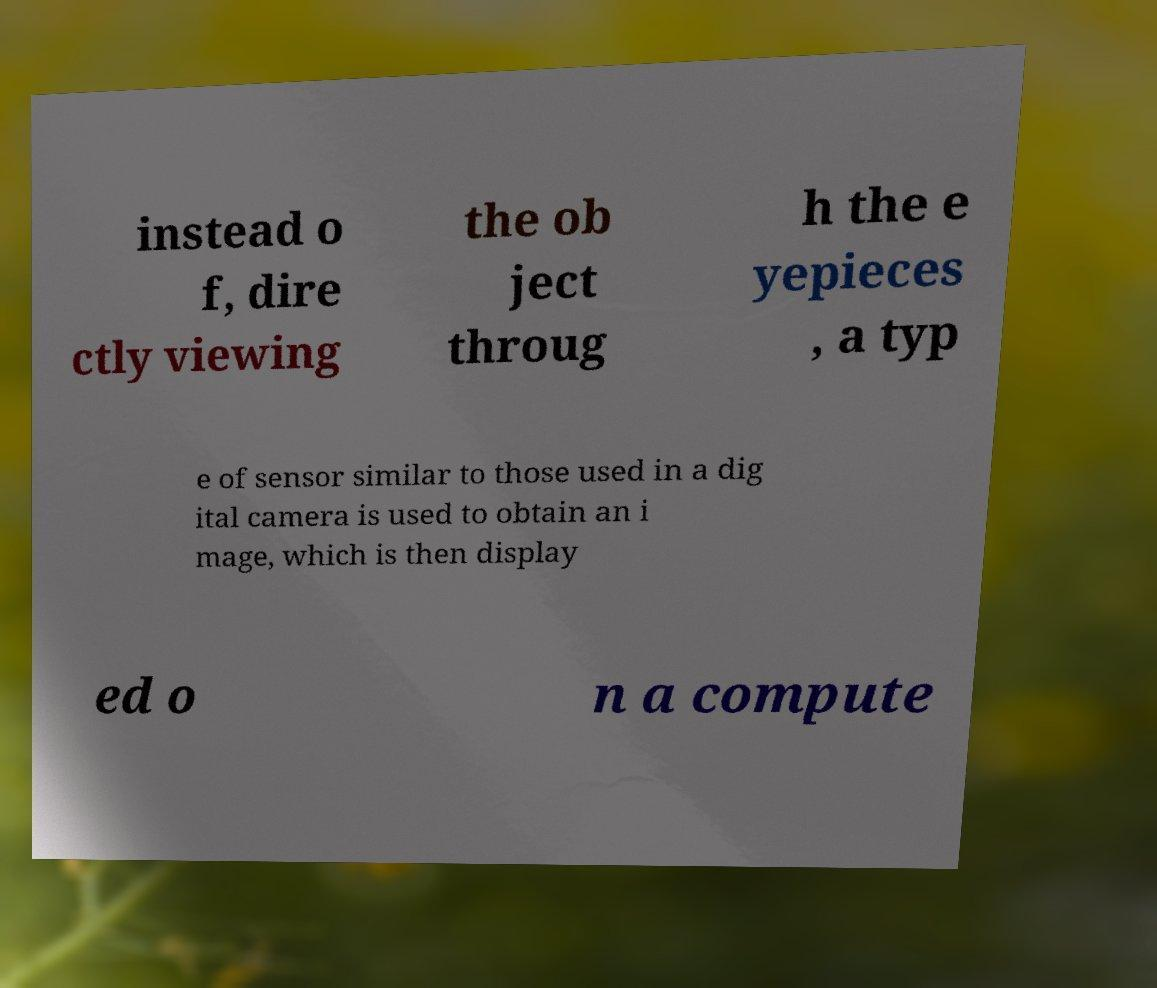For documentation purposes, I need the text within this image transcribed. Could you provide that? instead o f, dire ctly viewing the ob ject throug h the e yepieces , a typ e of sensor similar to those used in a dig ital camera is used to obtain an i mage, which is then display ed o n a compute 